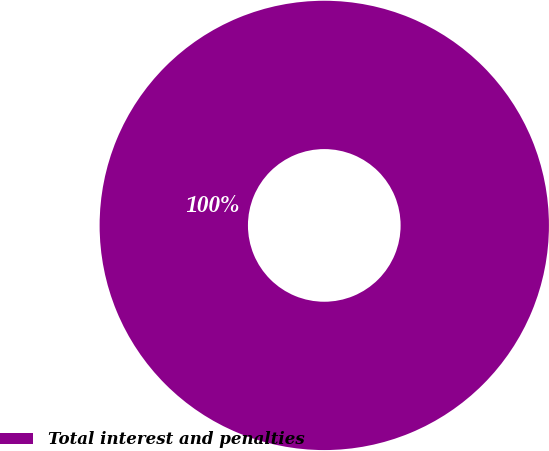Convert chart to OTSL. <chart><loc_0><loc_0><loc_500><loc_500><pie_chart><fcel>Total interest and penalties<nl><fcel>100.0%<nl></chart> 